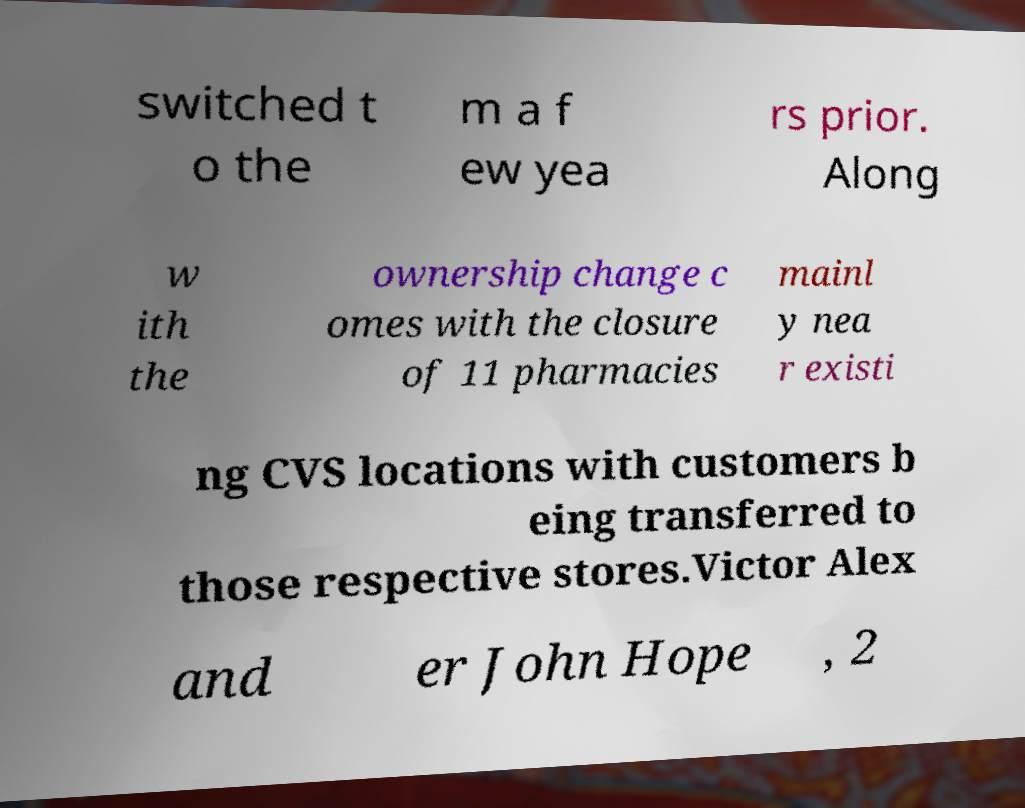Could you extract and type out the text from this image? switched t o the m a f ew yea rs prior. Along w ith the ownership change c omes with the closure of 11 pharmacies mainl y nea r existi ng CVS locations with customers b eing transferred to those respective stores.Victor Alex and er John Hope , 2 